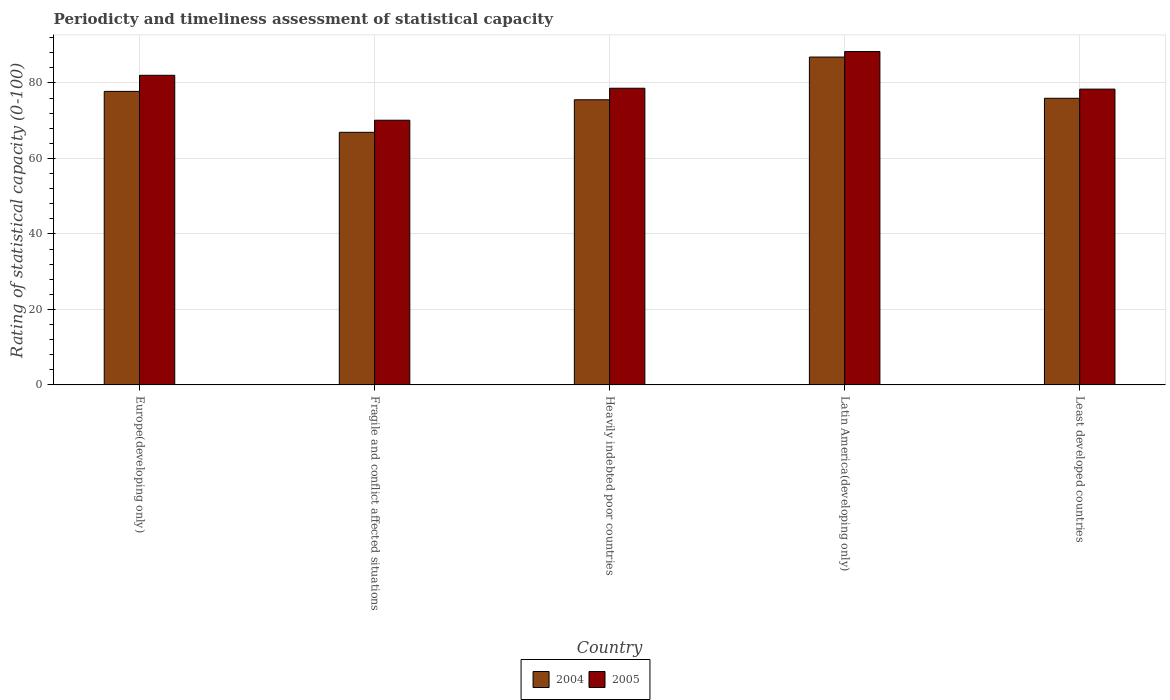Are the number of bars per tick equal to the number of legend labels?
Ensure brevity in your answer.  Yes. Are the number of bars on each tick of the X-axis equal?
Keep it short and to the point. Yes. How many bars are there on the 4th tick from the left?
Your answer should be compact. 2. What is the label of the 3rd group of bars from the left?
Your response must be concise. Heavily indebted poor countries. What is the rating of statistical capacity in 2005 in Europe(developing only)?
Offer a terse response. 82.04. Across all countries, what is the maximum rating of statistical capacity in 2005?
Your answer should be very brief. 88.33. Across all countries, what is the minimum rating of statistical capacity in 2004?
Your response must be concise. 66.93. In which country was the rating of statistical capacity in 2004 maximum?
Your response must be concise. Latin America(developing only). In which country was the rating of statistical capacity in 2005 minimum?
Keep it short and to the point. Fragile and conflict affected situations. What is the total rating of statistical capacity in 2004 in the graph?
Offer a very short reply. 383.09. What is the difference between the rating of statistical capacity in 2004 in Latin America(developing only) and that in Least developed countries?
Your answer should be compact. 10.93. What is the difference between the rating of statistical capacity in 2004 in Heavily indebted poor countries and the rating of statistical capacity in 2005 in Least developed countries?
Make the answer very short. -2.82. What is the average rating of statistical capacity in 2004 per country?
Your response must be concise. 76.62. What is the difference between the rating of statistical capacity of/in 2004 and rating of statistical capacity of/in 2005 in Heavily indebted poor countries?
Offer a very short reply. -3.06. What is the ratio of the rating of statistical capacity in 2004 in Heavily indebted poor countries to that in Latin America(developing only)?
Make the answer very short. 0.87. What is the difference between the highest and the second highest rating of statistical capacity in 2005?
Provide a succinct answer. 6.3. What is the difference between the highest and the lowest rating of statistical capacity in 2004?
Provide a short and direct response. 19.94. Is the sum of the rating of statistical capacity in 2004 in Heavily indebted poor countries and Latin America(developing only) greater than the maximum rating of statistical capacity in 2005 across all countries?
Your answer should be compact. Yes. What is the difference between two consecutive major ticks on the Y-axis?
Offer a very short reply. 20. What is the title of the graph?
Give a very brief answer. Periodicty and timeliness assessment of statistical capacity. What is the label or title of the Y-axis?
Provide a short and direct response. Rating of statistical capacity (0-100). What is the Rating of statistical capacity (0-100) in 2004 in Europe(developing only)?
Ensure brevity in your answer.  77.78. What is the Rating of statistical capacity (0-100) in 2005 in Europe(developing only)?
Keep it short and to the point. 82.04. What is the Rating of statistical capacity (0-100) of 2004 in Fragile and conflict affected situations?
Offer a very short reply. 66.93. What is the Rating of statistical capacity (0-100) of 2005 in Fragile and conflict affected situations?
Make the answer very short. 70.13. What is the Rating of statistical capacity (0-100) in 2004 in Heavily indebted poor countries?
Provide a succinct answer. 75.56. What is the Rating of statistical capacity (0-100) of 2005 in Heavily indebted poor countries?
Offer a very short reply. 78.61. What is the Rating of statistical capacity (0-100) in 2004 in Latin America(developing only)?
Ensure brevity in your answer.  86.88. What is the Rating of statistical capacity (0-100) of 2005 in Latin America(developing only)?
Your answer should be very brief. 88.33. What is the Rating of statistical capacity (0-100) in 2004 in Least developed countries?
Provide a succinct answer. 75.95. What is the Rating of statistical capacity (0-100) in 2005 in Least developed countries?
Ensure brevity in your answer.  78.38. Across all countries, what is the maximum Rating of statistical capacity (0-100) of 2004?
Provide a succinct answer. 86.88. Across all countries, what is the maximum Rating of statistical capacity (0-100) in 2005?
Your response must be concise. 88.33. Across all countries, what is the minimum Rating of statistical capacity (0-100) of 2004?
Ensure brevity in your answer.  66.93. Across all countries, what is the minimum Rating of statistical capacity (0-100) in 2005?
Keep it short and to the point. 70.13. What is the total Rating of statistical capacity (0-100) of 2004 in the graph?
Offer a terse response. 383.09. What is the total Rating of statistical capacity (0-100) of 2005 in the graph?
Keep it short and to the point. 397.49. What is the difference between the Rating of statistical capacity (0-100) in 2004 in Europe(developing only) and that in Fragile and conflict affected situations?
Offer a very short reply. 10.84. What is the difference between the Rating of statistical capacity (0-100) of 2005 in Europe(developing only) and that in Fragile and conflict affected situations?
Offer a terse response. 11.9. What is the difference between the Rating of statistical capacity (0-100) of 2004 in Europe(developing only) and that in Heavily indebted poor countries?
Your answer should be compact. 2.22. What is the difference between the Rating of statistical capacity (0-100) of 2005 in Europe(developing only) and that in Heavily indebted poor countries?
Offer a terse response. 3.43. What is the difference between the Rating of statistical capacity (0-100) of 2004 in Europe(developing only) and that in Latin America(developing only)?
Make the answer very short. -9.1. What is the difference between the Rating of statistical capacity (0-100) of 2005 in Europe(developing only) and that in Latin America(developing only)?
Offer a very short reply. -6.3. What is the difference between the Rating of statistical capacity (0-100) in 2004 in Europe(developing only) and that in Least developed countries?
Offer a terse response. 1.83. What is the difference between the Rating of statistical capacity (0-100) of 2005 in Europe(developing only) and that in Least developed countries?
Make the answer very short. 3.66. What is the difference between the Rating of statistical capacity (0-100) in 2004 in Fragile and conflict affected situations and that in Heavily indebted poor countries?
Make the answer very short. -8.62. What is the difference between the Rating of statistical capacity (0-100) of 2005 in Fragile and conflict affected situations and that in Heavily indebted poor countries?
Your answer should be compact. -8.48. What is the difference between the Rating of statistical capacity (0-100) in 2004 in Fragile and conflict affected situations and that in Latin America(developing only)?
Your response must be concise. -19.94. What is the difference between the Rating of statistical capacity (0-100) of 2005 in Fragile and conflict affected situations and that in Latin America(developing only)?
Ensure brevity in your answer.  -18.2. What is the difference between the Rating of statistical capacity (0-100) in 2004 in Fragile and conflict affected situations and that in Least developed countries?
Make the answer very short. -9.01. What is the difference between the Rating of statistical capacity (0-100) in 2005 in Fragile and conflict affected situations and that in Least developed countries?
Give a very brief answer. -8.24. What is the difference between the Rating of statistical capacity (0-100) of 2004 in Heavily indebted poor countries and that in Latin America(developing only)?
Keep it short and to the point. -11.32. What is the difference between the Rating of statistical capacity (0-100) in 2005 in Heavily indebted poor countries and that in Latin America(developing only)?
Keep it short and to the point. -9.72. What is the difference between the Rating of statistical capacity (0-100) of 2004 in Heavily indebted poor countries and that in Least developed countries?
Ensure brevity in your answer.  -0.39. What is the difference between the Rating of statistical capacity (0-100) in 2005 in Heavily indebted poor countries and that in Least developed countries?
Offer a very short reply. 0.23. What is the difference between the Rating of statistical capacity (0-100) in 2004 in Latin America(developing only) and that in Least developed countries?
Ensure brevity in your answer.  10.93. What is the difference between the Rating of statistical capacity (0-100) in 2005 in Latin America(developing only) and that in Least developed countries?
Offer a very short reply. 9.96. What is the difference between the Rating of statistical capacity (0-100) in 2004 in Europe(developing only) and the Rating of statistical capacity (0-100) in 2005 in Fragile and conflict affected situations?
Give a very brief answer. 7.64. What is the difference between the Rating of statistical capacity (0-100) in 2004 in Europe(developing only) and the Rating of statistical capacity (0-100) in 2005 in Latin America(developing only)?
Your answer should be very brief. -10.56. What is the difference between the Rating of statistical capacity (0-100) of 2004 in Europe(developing only) and the Rating of statistical capacity (0-100) of 2005 in Least developed countries?
Make the answer very short. -0.6. What is the difference between the Rating of statistical capacity (0-100) of 2004 in Fragile and conflict affected situations and the Rating of statistical capacity (0-100) of 2005 in Heavily indebted poor countries?
Make the answer very short. -11.68. What is the difference between the Rating of statistical capacity (0-100) of 2004 in Fragile and conflict affected situations and the Rating of statistical capacity (0-100) of 2005 in Latin America(developing only)?
Your answer should be compact. -21.4. What is the difference between the Rating of statistical capacity (0-100) of 2004 in Fragile and conflict affected situations and the Rating of statistical capacity (0-100) of 2005 in Least developed countries?
Keep it short and to the point. -11.45. What is the difference between the Rating of statistical capacity (0-100) of 2004 in Heavily indebted poor countries and the Rating of statistical capacity (0-100) of 2005 in Latin America(developing only)?
Provide a succinct answer. -12.78. What is the difference between the Rating of statistical capacity (0-100) in 2004 in Heavily indebted poor countries and the Rating of statistical capacity (0-100) in 2005 in Least developed countries?
Offer a terse response. -2.82. What is the difference between the Rating of statistical capacity (0-100) in 2004 in Latin America(developing only) and the Rating of statistical capacity (0-100) in 2005 in Least developed countries?
Your response must be concise. 8.5. What is the average Rating of statistical capacity (0-100) of 2004 per country?
Your answer should be compact. 76.62. What is the average Rating of statistical capacity (0-100) of 2005 per country?
Offer a very short reply. 79.5. What is the difference between the Rating of statistical capacity (0-100) of 2004 and Rating of statistical capacity (0-100) of 2005 in Europe(developing only)?
Ensure brevity in your answer.  -4.26. What is the difference between the Rating of statistical capacity (0-100) of 2004 and Rating of statistical capacity (0-100) of 2005 in Heavily indebted poor countries?
Offer a terse response. -3.06. What is the difference between the Rating of statistical capacity (0-100) of 2004 and Rating of statistical capacity (0-100) of 2005 in Latin America(developing only)?
Your answer should be very brief. -1.46. What is the difference between the Rating of statistical capacity (0-100) in 2004 and Rating of statistical capacity (0-100) in 2005 in Least developed countries?
Offer a terse response. -2.43. What is the ratio of the Rating of statistical capacity (0-100) of 2004 in Europe(developing only) to that in Fragile and conflict affected situations?
Keep it short and to the point. 1.16. What is the ratio of the Rating of statistical capacity (0-100) in 2005 in Europe(developing only) to that in Fragile and conflict affected situations?
Your response must be concise. 1.17. What is the ratio of the Rating of statistical capacity (0-100) in 2004 in Europe(developing only) to that in Heavily indebted poor countries?
Keep it short and to the point. 1.03. What is the ratio of the Rating of statistical capacity (0-100) in 2005 in Europe(developing only) to that in Heavily indebted poor countries?
Ensure brevity in your answer.  1.04. What is the ratio of the Rating of statistical capacity (0-100) of 2004 in Europe(developing only) to that in Latin America(developing only)?
Make the answer very short. 0.9. What is the ratio of the Rating of statistical capacity (0-100) in 2005 in Europe(developing only) to that in Latin America(developing only)?
Offer a very short reply. 0.93. What is the ratio of the Rating of statistical capacity (0-100) of 2004 in Europe(developing only) to that in Least developed countries?
Make the answer very short. 1.02. What is the ratio of the Rating of statistical capacity (0-100) in 2005 in Europe(developing only) to that in Least developed countries?
Offer a terse response. 1.05. What is the ratio of the Rating of statistical capacity (0-100) of 2004 in Fragile and conflict affected situations to that in Heavily indebted poor countries?
Make the answer very short. 0.89. What is the ratio of the Rating of statistical capacity (0-100) in 2005 in Fragile and conflict affected situations to that in Heavily indebted poor countries?
Offer a very short reply. 0.89. What is the ratio of the Rating of statistical capacity (0-100) in 2004 in Fragile and conflict affected situations to that in Latin America(developing only)?
Ensure brevity in your answer.  0.77. What is the ratio of the Rating of statistical capacity (0-100) in 2005 in Fragile and conflict affected situations to that in Latin America(developing only)?
Offer a very short reply. 0.79. What is the ratio of the Rating of statistical capacity (0-100) of 2004 in Fragile and conflict affected situations to that in Least developed countries?
Your response must be concise. 0.88. What is the ratio of the Rating of statistical capacity (0-100) of 2005 in Fragile and conflict affected situations to that in Least developed countries?
Your answer should be compact. 0.89. What is the ratio of the Rating of statistical capacity (0-100) in 2004 in Heavily indebted poor countries to that in Latin America(developing only)?
Offer a terse response. 0.87. What is the ratio of the Rating of statistical capacity (0-100) of 2005 in Heavily indebted poor countries to that in Latin America(developing only)?
Your answer should be compact. 0.89. What is the ratio of the Rating of statistical capacity (0-100) of 2004 in Heavily indebted poor countries to that in Least developed countries?
Offer a very short reply. 0.99. What is the ratio of the Rating of statistical capacity (0-100) of 2004 in Latin America(developing only) to that in Least developed countries?
Keep it short and to the point. 1.14. What is the ratio of the Rating of statistical capacity (0-100) in 2005 in Latin America(developing only) to that in Least developed countries?
Provide a short and direct response. 1.13. What is the difference between the highest and the second highest Rating of statistical capacity (0-100) of 2004?
Keep it short and to the point. 9.1. What is the difference between the highest and the second highest Rating of statistical capacity (0-100) of 2005?
Make the answer very short. 6.3. What is the difference between the highest and the lowest Rating of statistical capacity (0-100) in 2004?
Offer a terse response. 19.94. 